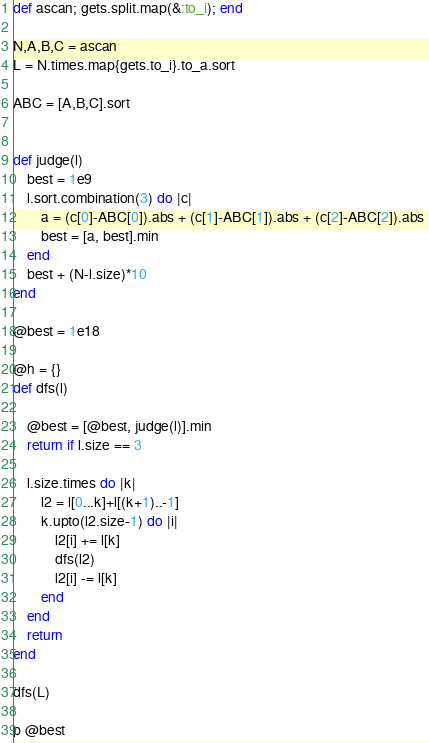<code> <loc_0><loc_0><loc_500><loc_500><_Ruby_>def ascan; gets.split.map(&:to_i); end

N,A,B,C = ascan
L = N.times.map{gets.to_i}.to_a.sort

ABC = [A,B,C].sort


def judge(l)
    best = 1e9
    l.sort.combination(3) do |c|
        a = (c[0]-ABC[0]).abs + (c[1]-ABC[1]).abs + (c[2]-ABC[2]).abs 
        best = [a, best].min
    end
    best + (N-l.size)*10
end

@best = 1e18

@h = {}
def dfs(l)
    
    @best = [@best, judge(l)].min
    return if l.size == 3
    
    l.size.times do |k|
        l2 = l[0...k]+l[(k+1)..-1]
        k.upto(l2.size-1) do |i|
            l2[i] += l[k]
            dfs(l2)
            l2[i] -= l[k]
        end
    end
    return
end

dfs(L)

p @best</code> 